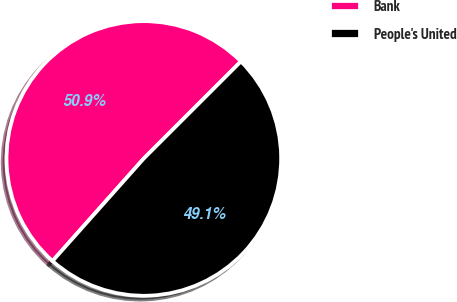Convert chart. <chart><loc_0><loc_0><loc_500><loc_500><pie_chart><fcel>Bank<fcel>People's United<nl><fcel>50.93%<fcel>49.07%<nl></chart> 